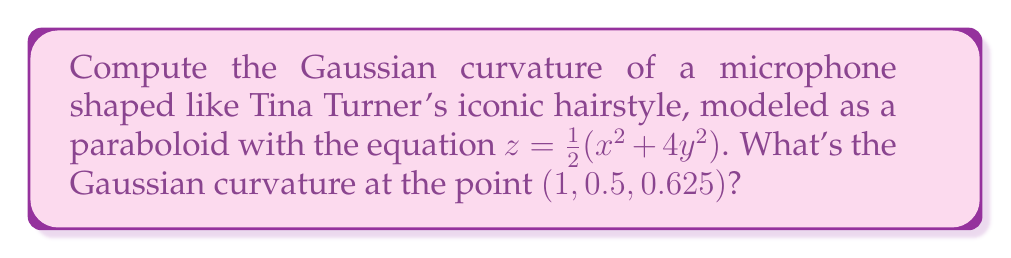Show me your answer to this math problem. Let's approach this step-by-step:

1) For a surface defined by $z = f(x,y)$, the Gaussian curvature K is given by:

   $$K = \frac{f_{xx}f_{yy} - f_{xy}^2}{(1 + f_x^2 + f_y^2)^2}$$

2) First, let's calculate the partial derivatives:
   
   $f_x = x$
   $f_y = 4y$
   $f_{xx} = 1$
   $f_{yy} = 4$
   $f_{xy} = 0$

3) Now, let's substitute these into the formula:

   $$K = \frac{(1)(4) - (0)^2}{(1 + x^2 + 16y^2)^2}$$

4) Simplify:

   $$K = \frac{4}{(1 + x^2 + 16y^2)^2}$$

5) At the point (1, 0.5, 0.625), we need to calculate:

   $$K = \frac{4}{(1 + 1^2 + 16(0.5)^2)^2}$$

6) Simplify:

   $$K = \frac{4}{(1 + 1 + 4)^2} = \frac{4}{36} = \frac{1}{9}$$

Thus, the Gaussian curvature at the point (1, 0.5, 0.625) is $\frac{1}{9}$.
Answer: $\frac{1}{9}$ 